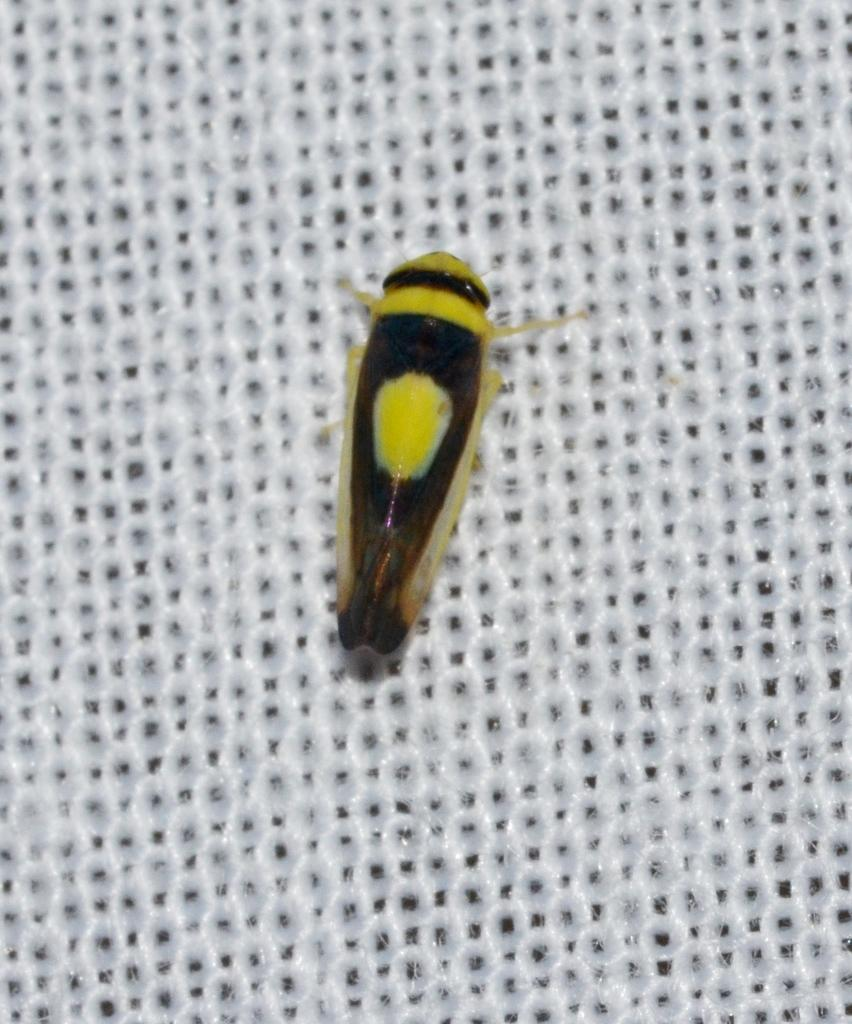What type of creature can be seen in the image? There is an insect in the image. Where is the insect located in the image? The insect is in the middle of a white mesh. What type of breakfast is the insect eating in the image? There is no breakfast present in the image, as it only features an insect in the middle of a white mesh. 